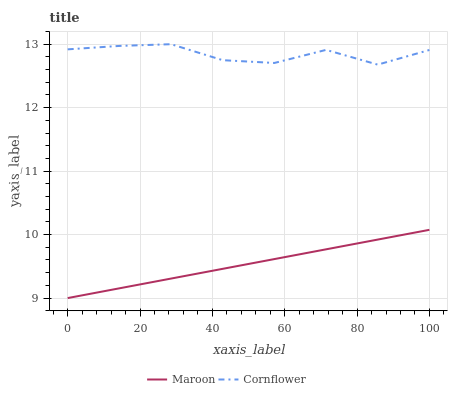Does Maroon have the minimum area under the curve?
Answer yes or no. Yes. Does Cornflower have the maximum area under the curve?
Answer yes or no. Yes. Does Maroon have the maximum area under the curve?
Answer yes or no. No. Is Maroon the smoothest?
Answer yes or no. Yes. Is Cornflower the roughest?
Answer yes or no. Yes. Is Maroon the roughest?
Answer yes or no. No. Does Maroon have the lowest value?
Answer yes or no. Yes. Does Cornflower have the highest value?
Answer yes or no. Yes. Does Maroon have the highest value?
Answer yes or no. No. Is Maroon less than Cornflower?
Answer yes or no. Yes. Is Cornflower greater than Maroon?
Answer yes or no. Yes. Does Maroon intersect Cornflower?
Answer yes or no. No. 